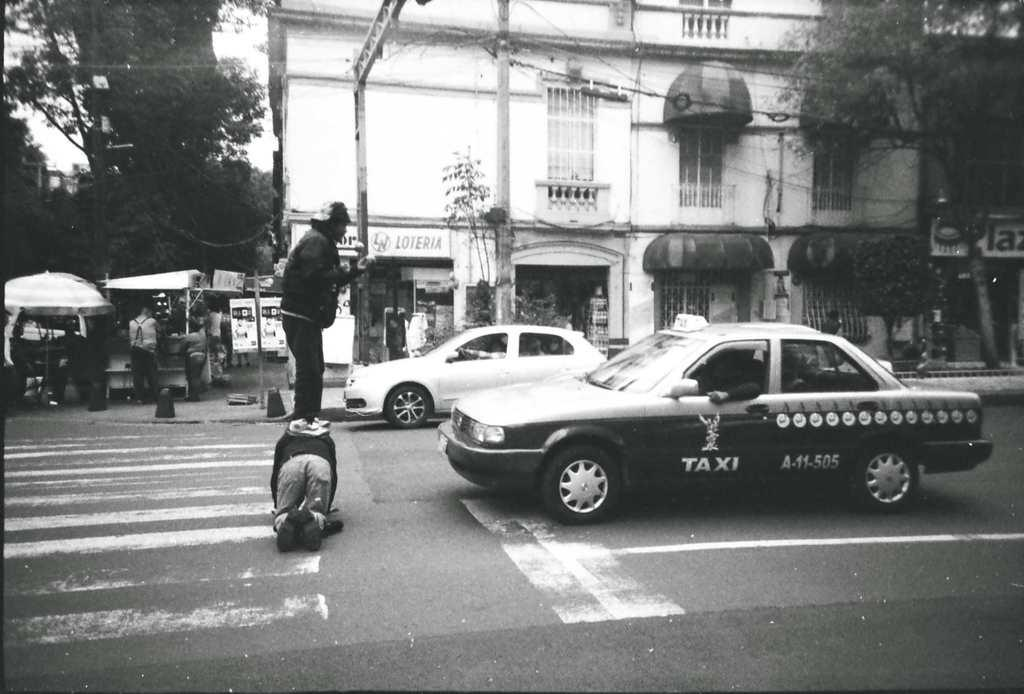Provide a one-sentence caption for the provided image. Two men stand in front of a taxi to impede it. 